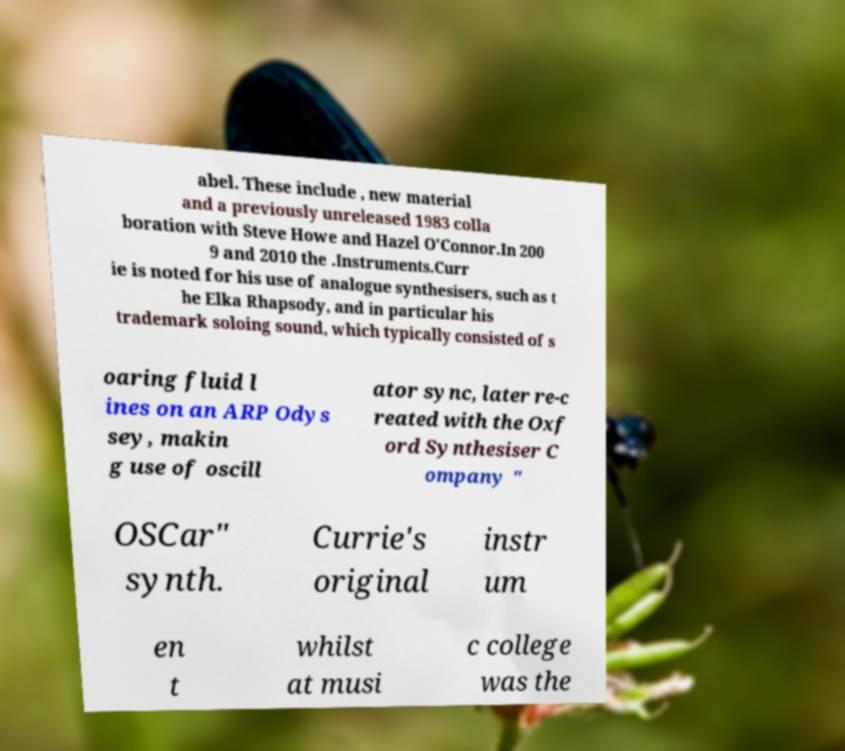Please identify and transcribe the text found in this image. abel. These include , new material and a previously unreleased 1983 colla boration with Steve Howe and Hazel O'Connor.In 200 9 and 2010 the .Instruments.Curr ie is noted for his use of analogue synthesisers, such as t he Elka Rhapsody, and in particular his trademark soloing sound, which typically consisted of s oaring fluid l ines on an ARP Odys sey, makin g use of oscill ator sync, later re-c reated with the Oxf ord Synthesiser C ompany " OSCar" synth. Currie's original instr um en t whilst at musi c college was the 